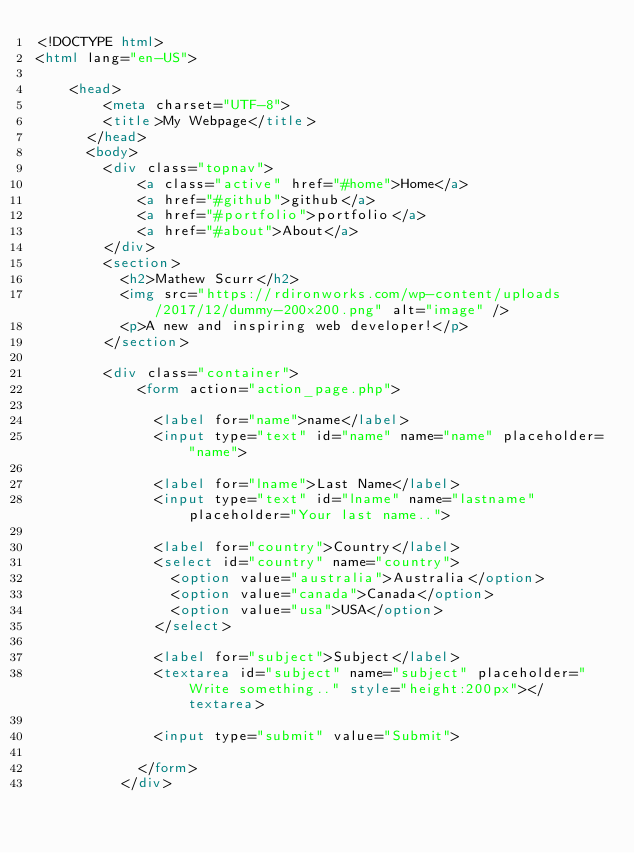<code> <loc_0><loc_0><loc_500><loc_500><_HTML_><!DOCTYPE html>
<html lang="en-US">

    <head>
        <meta charset="UTF-8">
        <title>My Webpage</title>
      </head>
      <body>
        <div class="topnav">
            <a class="active" href="#home">Home</a>
            <a href="#github">github</a>
            <a href="#portfolio">portfolio</a>
            <a href="#about">About</a>
        </div>
        <section>
          <h2>Mathew Scurr</h2>
          <img src="https://rdironworks.com/wp-content/uploads/2017/12/dummy-200x200.png" alt="image" />
          <p>A new and inspiring web developer!</p>
        </section>
    
        <div class="container">
            <form action="action_page.php">
          
              <label for="name">name</label>
              <input type="text" id="name" name="name" placeholder="name">
          
              <label for="lname">Last Name</label>
              <input type="text" id="lname" name="lastname" placeholder="Your last name..">
          
              <label for="country">Country</label>
              <select id="country" name="country">
                <option value="australia">Australia</option>
                <option value="canada">Canada</option>
                <option value="usa">USA</option>
              </select>
          
              <label for="subject">Subject</label>
              <textarea id="subject" name="subject" placeholder="Write something.." style="height:200px"></textarea>
          
              <input type="submit" value="Submit">
          
            </form>
          </div></code> 